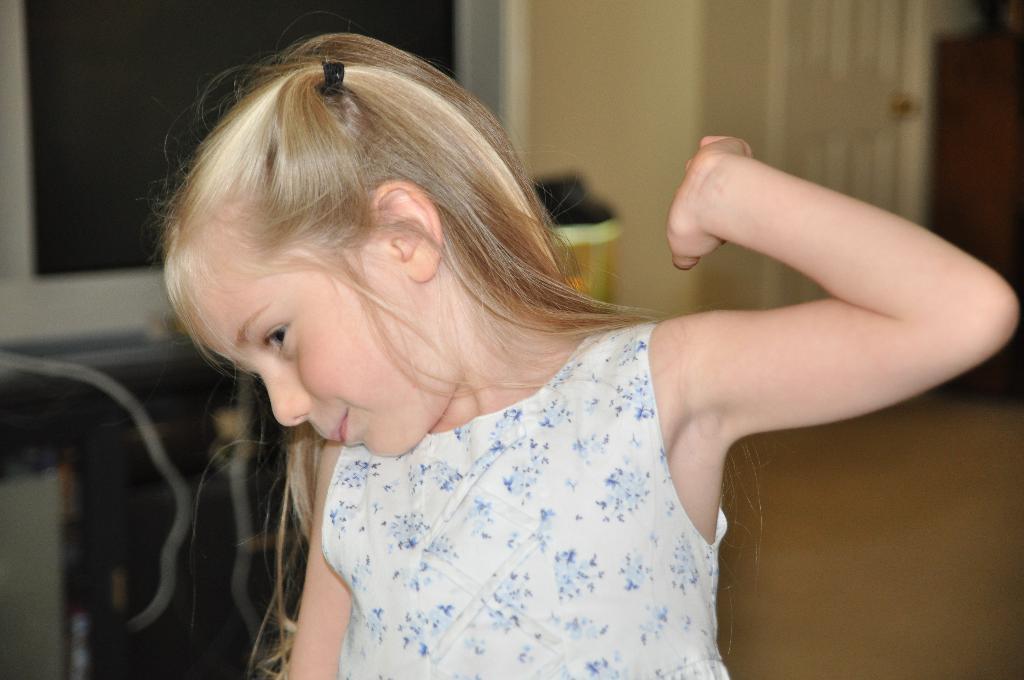In one or two sentences, can you explain what this image depicts? This image is taken indoors. In the background there is a wall and there are a few things. On the right side of the image there is a door and there is a floor. In the middle of the image there is a kid. 